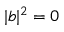Convert formula to latex. <formula><loc_0><loc_0><loc_500><loc_500>| b | ^ { 2 } = 0</formula> 